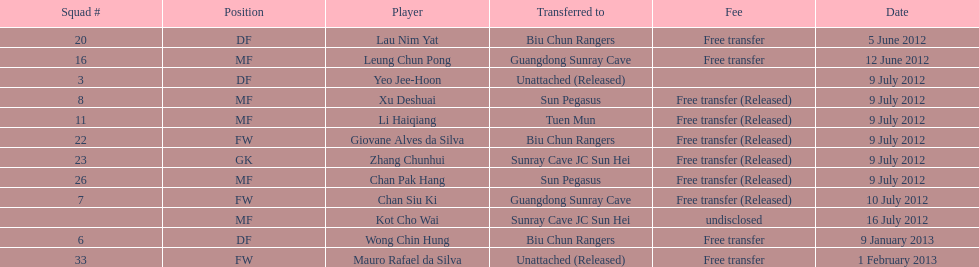Wong chin hung was transferred to his new team on what date? 9 January 2013. 